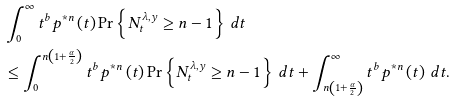<formula> <loc_0><loc_0><loc_500><loc_500>& \int _ { 0 } ^ { \infty } t ^ { b } p ^ { \ast n } \left ( t \right ) \Pr \left \{ N _ { t } ^ { \lambda , y } \geq n - 1 \right \} \, d t \\ & \leq \int _ { 0 } ^ { n \left ( 1 + \frac { \alpha } { 2 } \right ) } t ^ { b } p ^ { \ast n } \left ( t \right ) \Pr \left \{ N _ { t } ^ { \lambda , y } \geq n - 1 \right \} \, d t + \int _ { n \left ( 1 + \frac { \alpha } { 2 } \right ) } ^ { \infty } t ^ { b } p ^ { \ast n } \left ( t \right ) \, d t .</formula> 